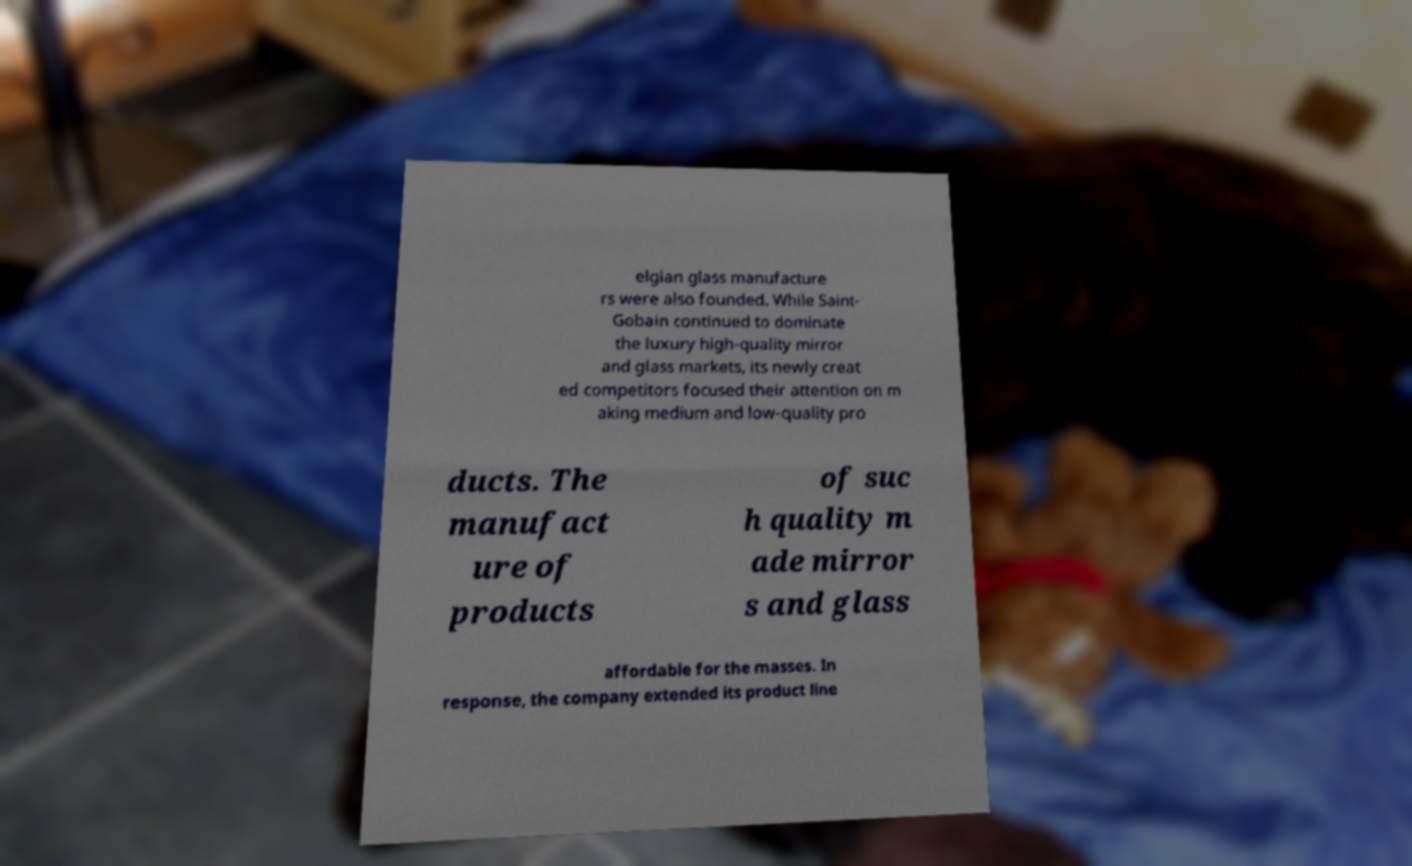Please identify and transcribe the text found in this image. elgian glass manufacture rs were also founded. While Saint- Gobain continued to dominate the luxury high-quality mirror and glass markets, its newly creat ed competitors focused their attention on m aking medium and low-quality pro ducts. The manufact ure of products of suc h quality m ade mirror s and glass affordable for the masses. In response, the company extended its product line 